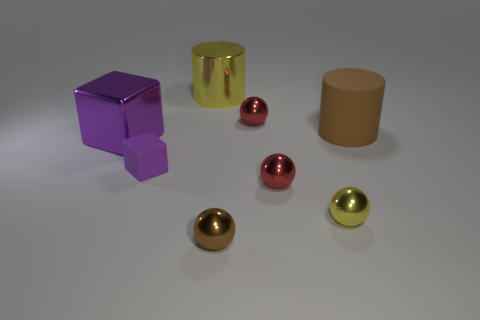Subtract all gray spheres. Subtract all yellow blocks. How many spheres are left? 4 Add 1 brown objects. How many objects exist? 9 Subtract all blocks. How many objects are left? 6 Add 8 brown metal balls. How many brown metal balls are left? 9 Add 5 tiny red things. How many tiny red things exist? 7 Subtract 1 yellow cylinders. How many objects are left? 7 Subtract all big yellow metallic things. Subtract all big rubber objects. How many objects are left? 6 